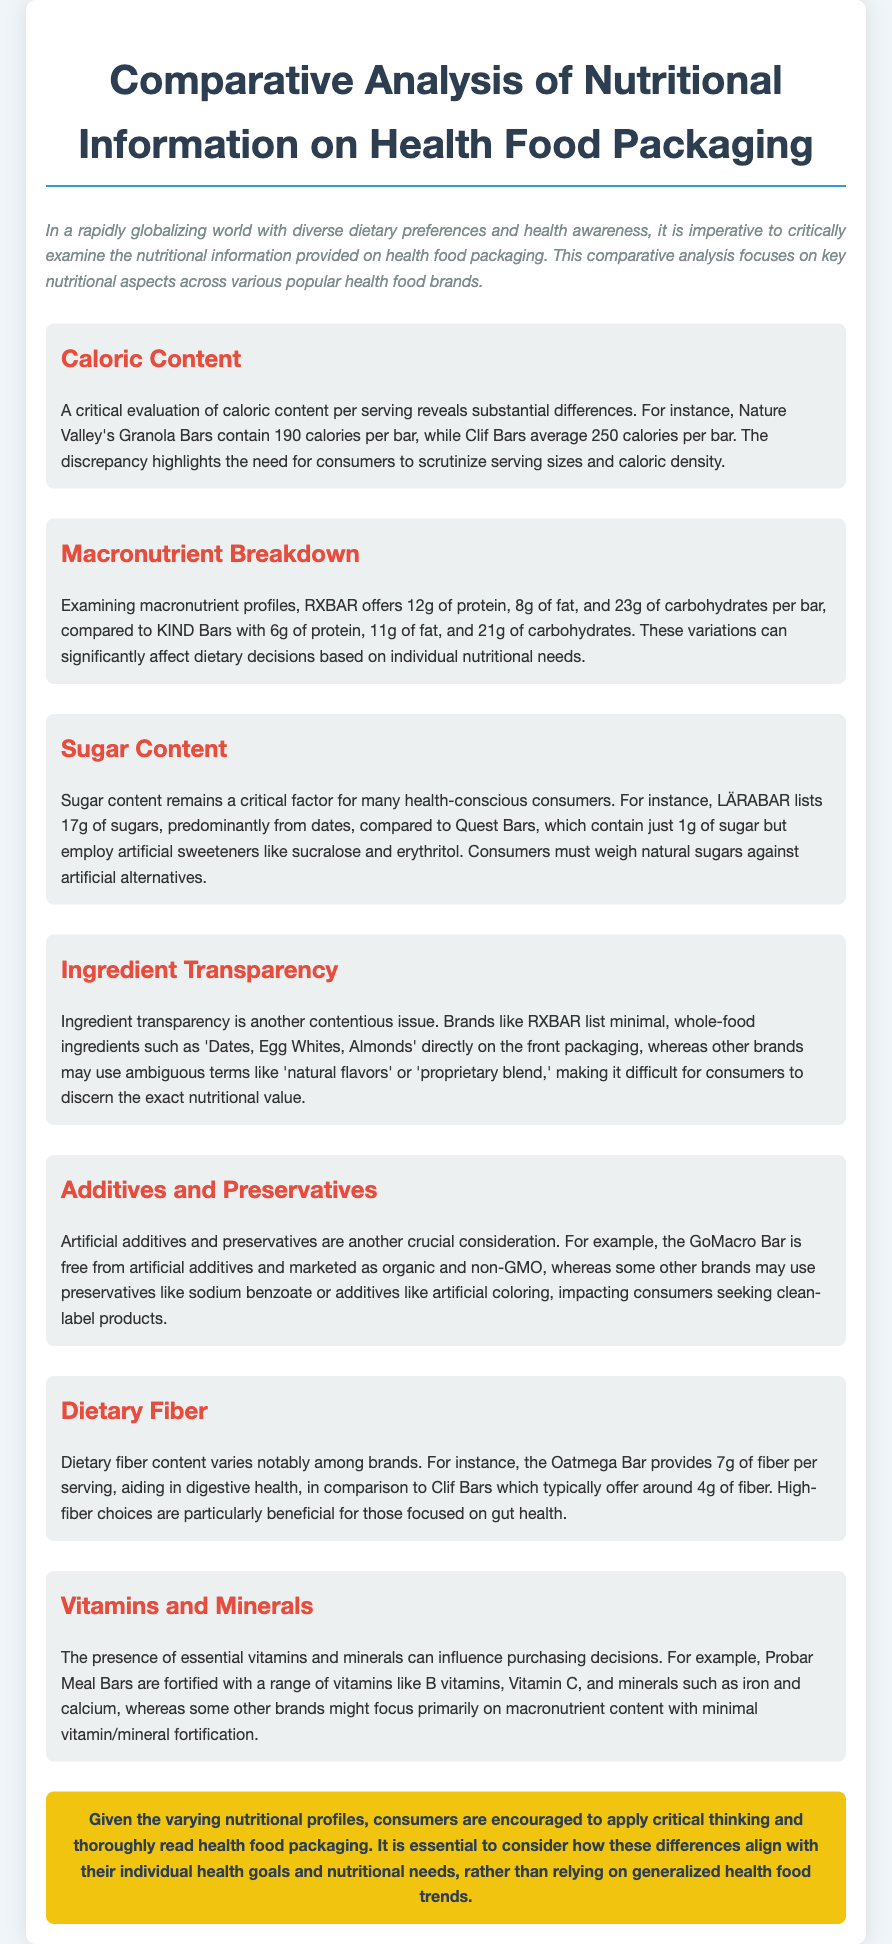What is the caloric content of Nature Valley's Granola Bars? Nature Valley's Granola Bars contain 190 calories per bar as stated in the section on caloric content.
Answer: 190 calories Which brand offers the highest protein content per bar? RXBAR offers 12g of protein per bar, which is higher than KIND Bars' protein content in the macronutrient breakdown section.
Answer: RXBAR What is the sugar content in Quest Bars? Quest Bars contain 1g of sugar, which is mentioned in the sugar content section.
Answer: 1g What type of ingredients does RXBAR emphasize? RXBAR lists minimal, whole-food ingredients such as "Dates, Egg Whites, Almonds" as highlighted in the ingredient transparency section.
Answer: Whole-food ingredients How much dietary fiber does Oatmega Bar provide? The Oatmega Bar provides 7g of fiber per serving, noted in the dietary fiber section.
Answer: 7g What is a critical aspect regarding ingredient transparency? The use of ambiguous terms like "natural flavors" makes it difficult for consumers to discern exact nutritional values, as discussed in the ingredient transparency section.
Answer: Ambiguous terms Why do consumers need to consider caloric density? The discrepancy in caloric content highlights the need for consumers to scrutinize serving sizes and caloric density as emphasized in the caloric content section.
Answer: Scrutinize serving sizes Which vitamins are fortified in Probar Meal Bars? Probar Meal Bars are fortified with a range of vitamins like B vitamins and Vitamin C, as mentioned in the vitamins and minerals section.
Answer: B vitamins and Vitamin C What type of additives does GoMacro Bar avoid? The GoMacro Bar is free from artificial additives, as pointed out in the additives and preservatives section.
Answer: Artificial additives 